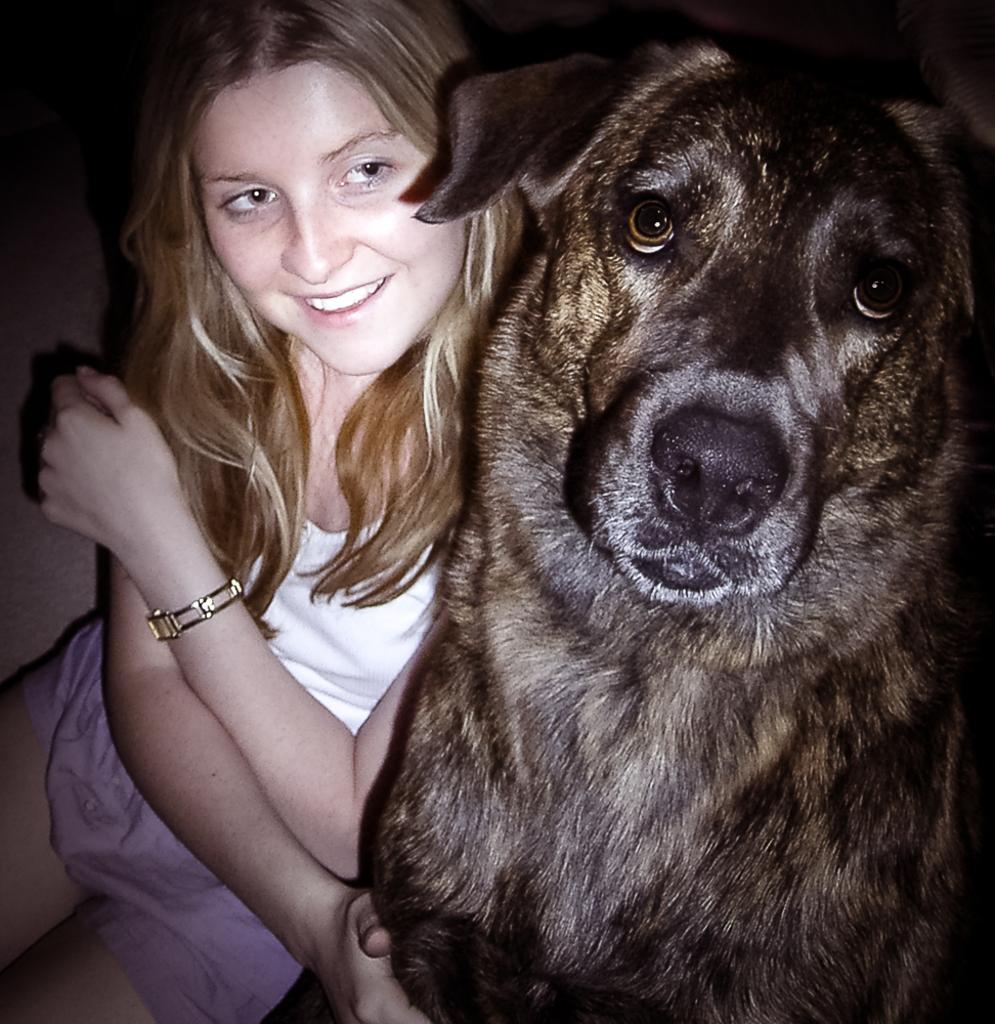Who is present in the image? There is a woman in the image. What type of animal is also present in the image? There is a black dog in the image. What is the woman wearing in the image? The woman is wearing a white dress. What type of stove can be seen in the image? There is no stove present in the image. How many apples are visible in the image? There are no apples present in the image. 